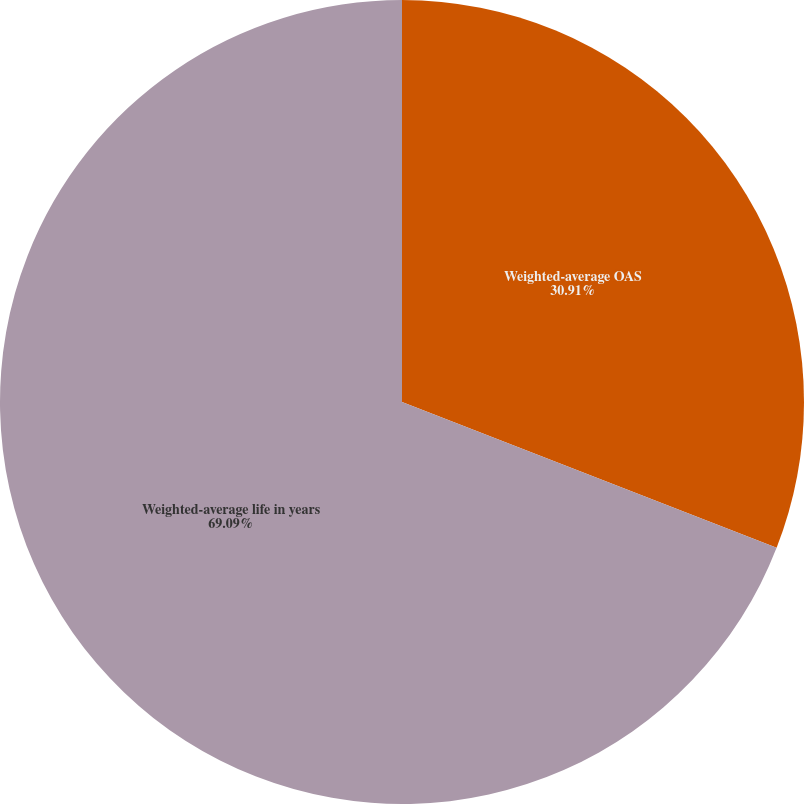<chart> <loc_0><loc_0><loc_500><loc_500><pie_chart><fcel>Weighted-average OAS<fcel>Weighted-average life in years<nl><fcel>30.91%<fcel>69.09%<nl></chart> 